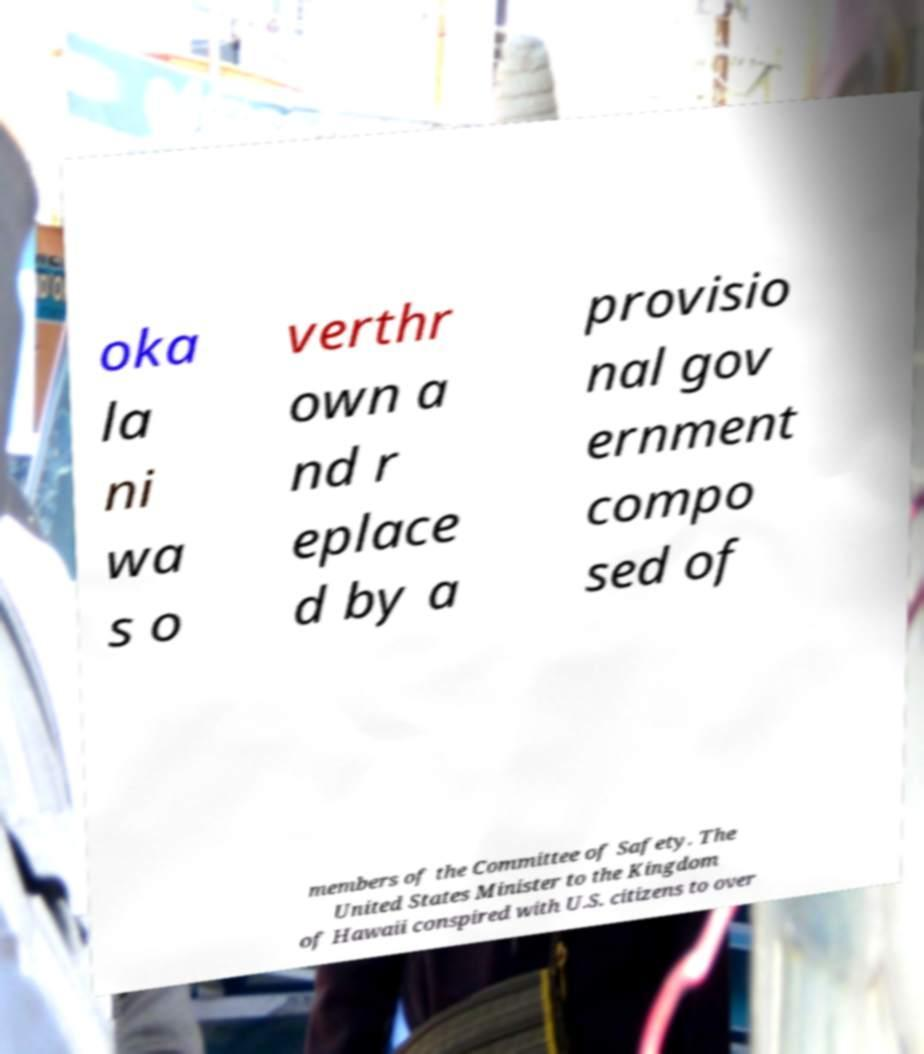For documentation purposes, I need the text within this image transcribed. Could you provide that? oka la ni wa s o verthr own a nd r eplace d by a provisio nal gov ernment compo sed of members of the Committee of Safety. The United States Minister to the Kingdom of Hawaii conspired with U.S. citizens to over 